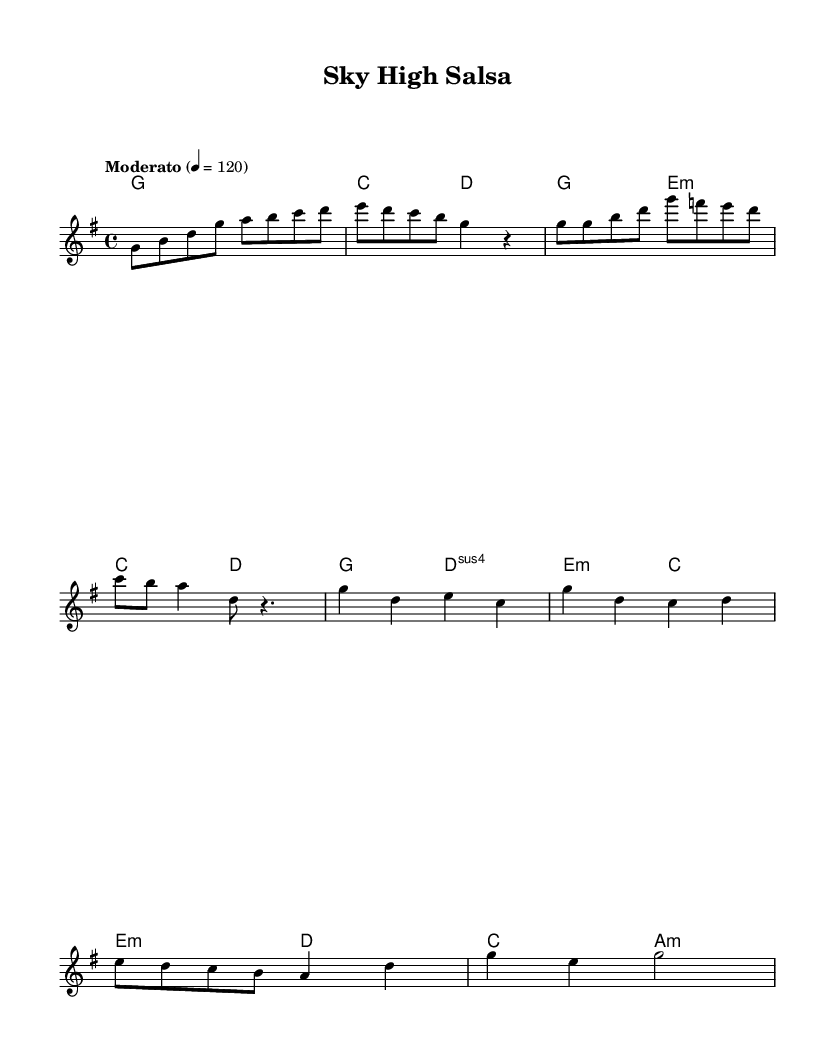What is the key signature of this music? The key signature indicated is G major, which has one sharp (F#). This is discerned by looking at the key signature at the beginning of the staff.
Answer: G major What is the time signature of this music? The time signature shown at the beginning is 4/4, indicating that there are four beats in each measure and the quarter note gets one beat. This is found just after the clef sign.
Answer: 4/4 What is the tempo marking for the piece? The tempo indicated is "Moderato" at 120 beats per minute, which tells musicians to play at a moderate speed. This is specified at the beginning of the score.
Answer: Moderato, 120 How many sections are there in the piece? There are four distinct sections: Intro, Verse, Chorus, and Bridge. These sections can be discerned by looking at the layout of the melody and the lyrical structure, which divides the music into identifiable parts.
Answer: Four What chords are played during the Chorus? The chords in the Chorus are G, D suspended fourth, E minor, and C. This conclusion is reached by examining the chord symbols provided during the specific section marked as the Chorus in the score.
Answer: G, Dsus4, Em, C What type of fusion does this piece represent? This music blends country and salsa rhythms, incorporating the influences of both styles into its structure. This is inferred from the style designation and the rhythmic patterns typically associated with Latin and country music.
Answer: Country and salsa Which chord is played at the beginning of the piece? The first chord specified in the score is G major. This is apparent in the introductory measures, as indicated in the harmonies section of the score.
Answer: G 